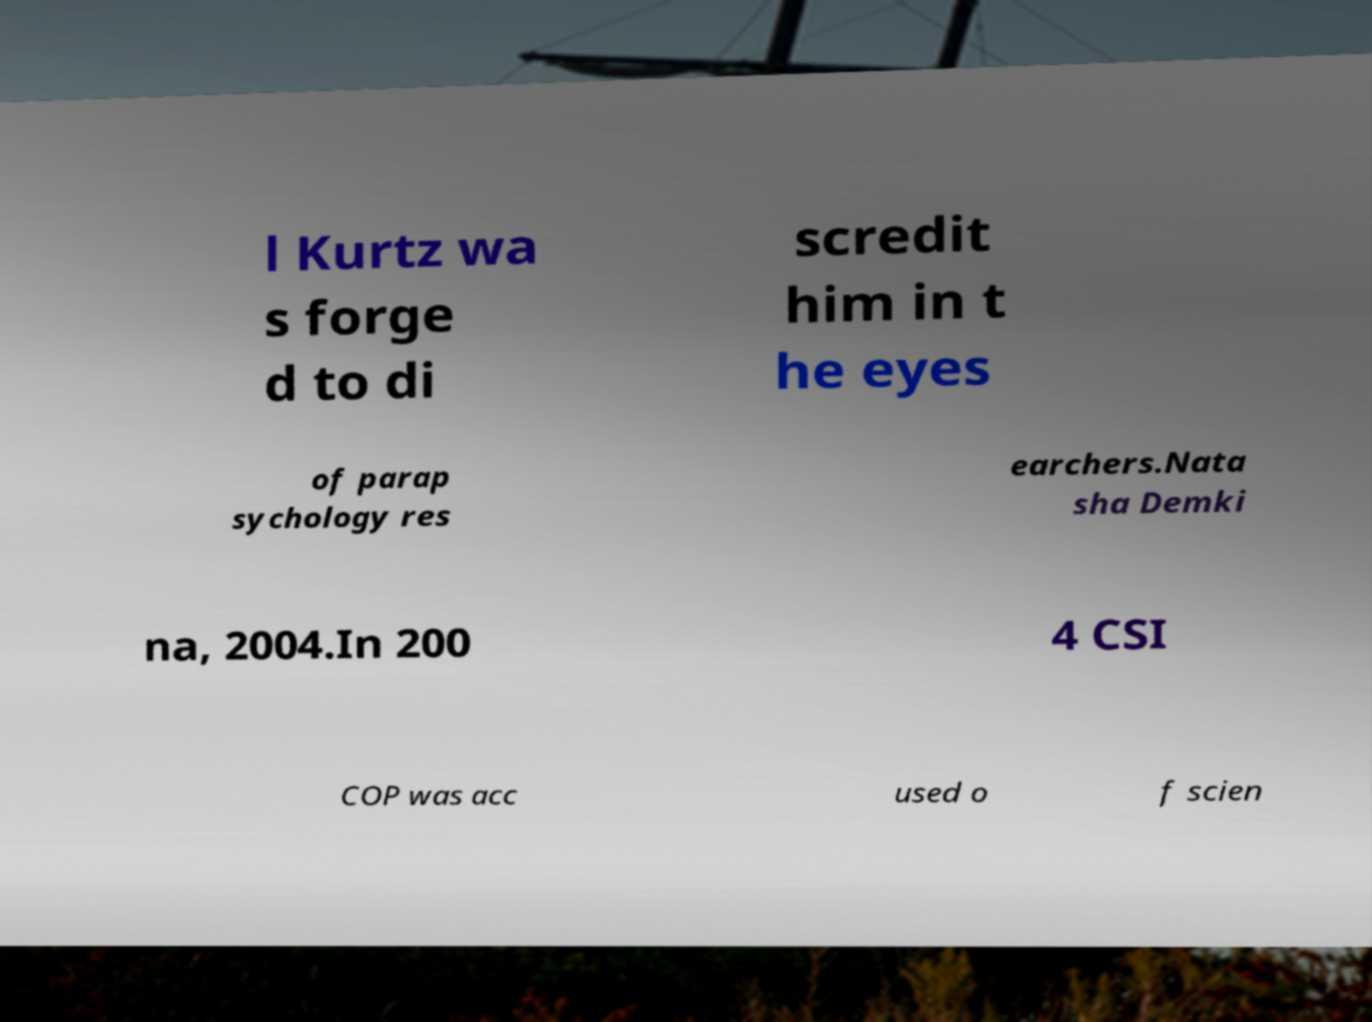I need the written content from this picture converted into text. Can you do that? l Kurtz wa s forge d to di scredit him in t he eyes of parap sychology res earchers.Nata sha Demki na, 2004.In 200 4 CSI COP was acc used o f scien 